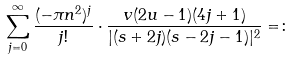Convert formula to latex. <formula><loc_0><loc_0><loc_500><loc_500>\sum _ { j = 0 } ^ { \infty } \frac { ( - \pi n ^ { 2 } ) ^ { j } } { j ! } \cdot \frac { v ( 2 u - 1 ) ( 4 j + 1 ) } { | ( s + 2 j ) ( s - 2 j - 1 ) | ^ { 2 } } = \colon</formula> 